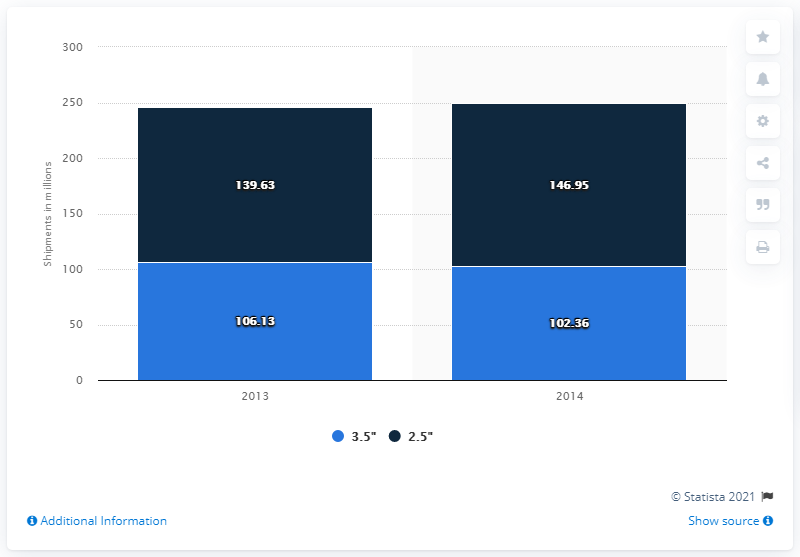What do the blue shades in the bar chart represent, and why are there two per year? The two shades of blue in the bar chart represent different sizes of shipments: dark blue shows shipments of 3.5" units while light blue shows 2.5" units. There are two bars per year to separately indicate the volume of shipments for each size category within that given year. Has there been an increase or decrease in shipments for either size over the years shown? From 2013 to 2014, there has been an increase in shipments of 3.5" units from 139.63 million to 146.95 million, which is an increase of approximately 5.25%. However, shipments of 2.5" units have decreased from 106.13 million to 102.36 million, indicating a decrease of roughly 3.56%. 